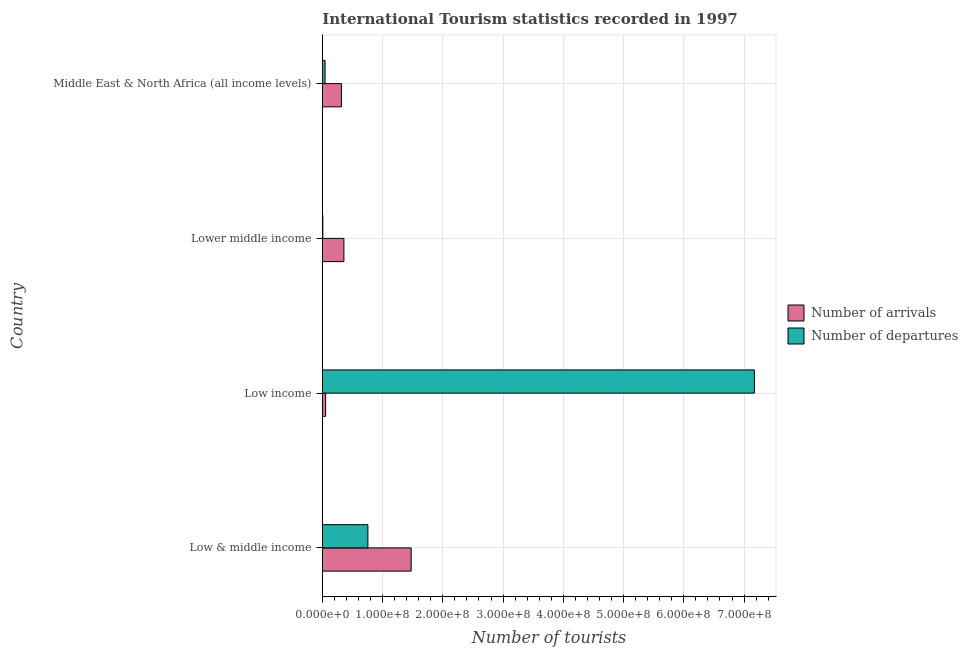How many groups of bars are there?
Ensure brevity in your answer.  4. How many bars are there on the 2nd tick from the top?
Ensure brevity in your answer.  2. How many bars are there on the 4th tick from the bottom?
Make the answer very short. 2. What is the number of tourist arrivals in Low & middle income?
Your answer should be very brief. 1.47e+08. Across all countries, what is the maximum number of tourist departures?
Provide a succinct answer. 7.17e+08. Across all countries, what is the minimum number of tourist arrivals?
Ensure brevity in your answer.  5.50e+06. In which country was the number of tourist arrivals maximum?
Your response must be concise. Low & middle income. In which country was the number of tourist departures minimum?
Give a very brief answer. Lower middle income. What is the total number of tourist arrivals in the graph?
Ensure brevity in your answer.  2.20e+08. What is the difference between the number of tourist arrivals in Low & middle income and that in Lower middle income?
Offer a very short reply. 1.12e+08. What is the difference between the number of tourist departures in Low & middle income and the number of tourist arrivals in Middle East & North Africa (all income levels)?
Provide a short and direct response. 4.39e+07. What is the average number of tourist departures per country?
Keep it short and to the point. 2.00e+08. What is the difference between the number of tourist arrivals and number of tourist departures in Middle East & North Africa (all income levels)?
Ensure brevity in your answer.  2.72e+07. What is the ratio of the number of tourist arrivals in Low income to that in Middle East & North Africa (all income levels)?
Your answer should be compact. 0.17. Is the number of tourist arrivals in Low & middle income less than that in Low income?
Provide a short and direct response. No. What is the difference between the highest and the second highest number of tourist arrivals?
Your answer should be compact. 1.12e+08. What is the difference between the highest and the lowest number of tourist departures?
Your response must be concise. 7.16e+08. In how many countries, is the number of tourist departures greater than the average number of tourist departures taken over all countries?
Give a very brief answer. 1. What does the 1st bar from the top in Low & middle income represents?
Give a very brief answer. Number of departures. What does the 1st bar from the bottom in Lower middle income represents?
Provide a succinct answer. Number of arrivals. How many bars are there?
Make the answer very short. 8. Are all the bars in the graph horizontal?
Provide a succinct answer. Yes. How many countries are there in the graph?
Offer a terse response. 4. Where does the legend appear in the graph?
Offer a very short reply. Center right. How are the legend labels stacked?
Provide a succinct answer. Vertical. What is the title of the graph?
Your answer should be very brief. International Tourism statistics recorded in 1997. Does "Number of departures" appear as one of the legend labels in the graph?
Give a very brief answer. Yes. What is the label or title of the X-axis?
Keep it short and to the point. Number of tourists. What is the label or title of the Y-axis?
Offer a very short reply. Country. What is the Number of tourists in Number of arrivals in Low & middle income?
Offer a terse response. 1.47e+08. What is the Number of tourists of Number of departures in Low & middle income?
Ensure brevity in your answer.  7.56e+07. What is the Number of tourists in Number of arrivals in Low income?
Keep it short and to the point. 5.50e+06. What is the Number of tourists in Number of departures in Low income?
Give a very brief answer. 7.17e+08. What is the Number of tourists of Number of arrivals in Lower middle income?
Offer a terse response. 3.58e+07. What is the Number of tourists in Number of departures in Lower middle income?
Make the answer very short. 8.27e+05. What is the Number of tourists in Number of arrivals in Middle East & North Africa (all income levels)?
Provide a succinct answer. 3.17e+07. What is the Number of tourists in Number of departures in Middle East & North Africa (all income levels)?
Make the answer very short. 4.52e+06. Across all countries, what is the maximum Number of tourists of Number of arrivals?
Offer a very short reply. 1.47e+08. Across all countries, what is the maximum Number of tourists in Number of departures?
Ensure brevity in your answer.  7.17e+08. Across all countries, what is the minimum Number of tourists in Number of arrivals?
Your answer should be very brief. 5.50e+06. Across all countries, what is the minimum Number of tourists of Number of departures?
Your answer should be very brief. 8.27e+05. What is the total Number of tourists in Number of arrivals in the graph?
Ensure brevity in your answer.  2.20e+08. What is the total Number of tourists of Number of departures in the graph?
Ensure brevity in your answer.  7.98e+08. What is the difference between the Number of tourists of Number of arrivals in Low & middle income and that in Low income?
Keep it short and to the point. 1.42e+08. What is the difference between the Number of tourists of Number of departures in Low & middle income and that in Low income?
Your answer should be very brief. -6.42e+08. What is the difference between the Number of tourists of Number of arrivals in Low & middle income and that in Lower middle income?
Make the answer very short. 1.12e+08. What is the difference between the Number of tourists in Number of departures in Low & middle income and that in Lower middle income?
Your response must be concise. 7.48e+07. What is the difference between the Number of tourists of Number of arrivals in Low & middle income and that in Middle East & North Africa (all income levels)?
Provide a short and direct response. 1.16e+08. What is the difference between the Number of tourists of Number of departures in Low & middle income and that in Middle East & North Africa (all income levels)?
Provide a short and direct response. 7.11e+07. What is the difference between the Number of tourists in Number of arrivals in Low income and that in Lower middle income?
Give a very brief answer. -3.03e+07. What is the difference between the Number of tourists in Number of departures in Low income and that in Lower middle income?
Offer a very short reply. 7.16e+08. What is the difference between the Number of tourists of Number of arrivals in Low income and that in Middle East & North Africa (all income levels)?
Ensure brevity in your answer.  -2.62e+07. What is the difference between the Number of tourists in Number of departures in Low income and that in Middle East & North Africa (all income levels)?
Give a very brief answer. 7.13e+08. What is the difference between the Number of tourists in Number of arrivals in Lower middle income and that in Middle East & North Africa (all income levels)?
Provide a short and direct response. 4.14e+06. What is the difference between the Number of tourists in Number of departures in Lower middle income and that in Middle East & North Africa (all income levels)?
Offer a terse response. -3.69e+06. What is the difference between the Number of tourists in Number of arrivals in Low & middle income and the Number of tourists in Number of departures in Low income?
Provide a succinct answer. -5.70e+08. What is the difference between the Number of tourists in Number of arrivals in Low & middle income and the Number of tourists in Number of departures in Lower middle income?
Offer a very short reply. 1.47e+08. What is the difference between the Number of tourists in Number of arrivals in Low & middle income and the Number of tourists in Number of departures in Middle East & North Africa (all income levels)?
Your answer should be compact. 1.43e+08. What is the difference between the Number of tourists of Number of arrivals in Low income and the Number of tourists of Number of departures in Lower middle income?
Offer a terse response. 4.68e+06. What is the difference between the Number of tourists in Number of arrivals in Low income and the Number of tourists in Number of departures in Middle East & North Africa (all income levels)?
Your answer should be compact. 9.86e+05. What is the difference between the Number of tourists of Number of arrivals in Lower middle income and the Number of tourists of Number of departures in Middle East & North Africa (all income levels)?
Give a very brief answer. 3.13e+07. What is the average Number of tourists of Number of arrivals per country?
Your answer should be compact. 5.51e+07. What is the average Number of tourists in Number of departures per country?
Give a very brief answer. 2.00e+08. What is the difference between the Number of tourists in Number of arrivals and Number of tourists in Number of departures in Low & middle income?
Offer a terse response. 7.18e+07. What is the difference between the Number of tourists of Number of arrivals and Number of tourists of Number of departures in Low income?
Provide a short and direct response. -7.12e+08. What is the difference between the Number of tourists of Number of arrivals and Number of tourists of Number of departures in Lower middle income?
Your response must be concise. 3.50e+07. What is the difference between the Number of tourists of Number of arrivals and Number of tourists of Number of departures in Middle East & North Africa (all income levels)?
Make the answer very short. 2.72e+07. What is the ratio of the Number of tourists in Number of arrivals in Low & middle income to that in Low income?
Your response must be concise. 26.79. What is the ratio of the Number of tourists of Number of departures in Low & middle income to that in Low income?
Make the answer very short. 0.11. What is the ratio of the Number of tourists of Number of arrivals in Low & middle income to that in Lower middle income?
Offer a very short reply. 4.12. What is the ratio of the Number of tourists in Number of departures in Low & middle income to that in Lower middle income?
Your answer should be compact. 91.44. What is the ratio of the Number of tourists in Number of arrivals in Low & middle income to that in Middle East & North Africa (all income levels)?
Give a very brief answer. 4.65. What is the ratio of the Number of tourists of Number of departures in Low & middle income to that in Middle East & North Africa (all income levels)?
Make the answer very short. 16.74. What is the ratio of the Number of tourists of Number of arrivals in Low income to that in Lower middle income?
Make the answer very short. 0.15. What is the ratio of the Number of tourists in Number of departures in Low income to that in Lower middle income?
Provide a succinct answer. 867.15. What is the ratio of the Number of tourists of Number of arrivals in Low income to that in Middle East & North Africa (all income levels)?
Provide a short and direct response. 0.17. What is the ratio of the Number of tourists in Number of departures in Low income to that in Middle East & North Africa (all income levels)?
Offer a very short reply. 158.76. What is the ratio of the Number of tourists in Number of arrivals in Lower middle income to that in Middle East & North Africa (all income levels)?
Offer a very short reply. 1.13. What is the ratio of the Number of tourists in Number of departures in Lower middle income to that in Middle East & North Africa (all income levels)?
Make the answer very short. 0.18. What is the difference between the highest and the second highest Number of tourists of Number of arrivals?
Ensure brevity in your answer.  1.12e+08. What is the difference between the highest and the second highest Number of tourists in Number of departures?
Your answer should be very brief. 6.42e+08. What is the difference between the highest and the lowest Number of tourists of Number of arrivals?
Your response must be concise. 1.42e+08. What is the difference between the highest and the lowest Number of tourists of Number of departures?
Make the answer very short. 7.16e+08. 